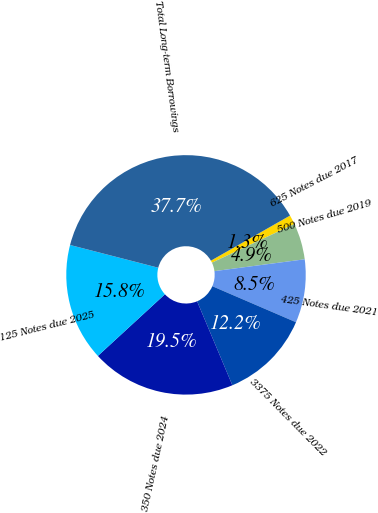Convert chart. <chart><loc_0><loc_0><loc_500><loc_500><pie_chart><fcel>625 Notes due 2017<fcel>500 Notes due 2019<fcel>425 Notes due 2021<fcel>3375 Notes due 2022<fcel>350 Notes due 2024<fcel>125 Notes due 2025<fcel>Total Long-term Borrowings<nl><fcel>1.26%<fcel>4.91%<fcel>8.55%<fcel>12.2%<fcel>19.5%<fcel>15.85%<fcel>37.74%<nl></chart> 